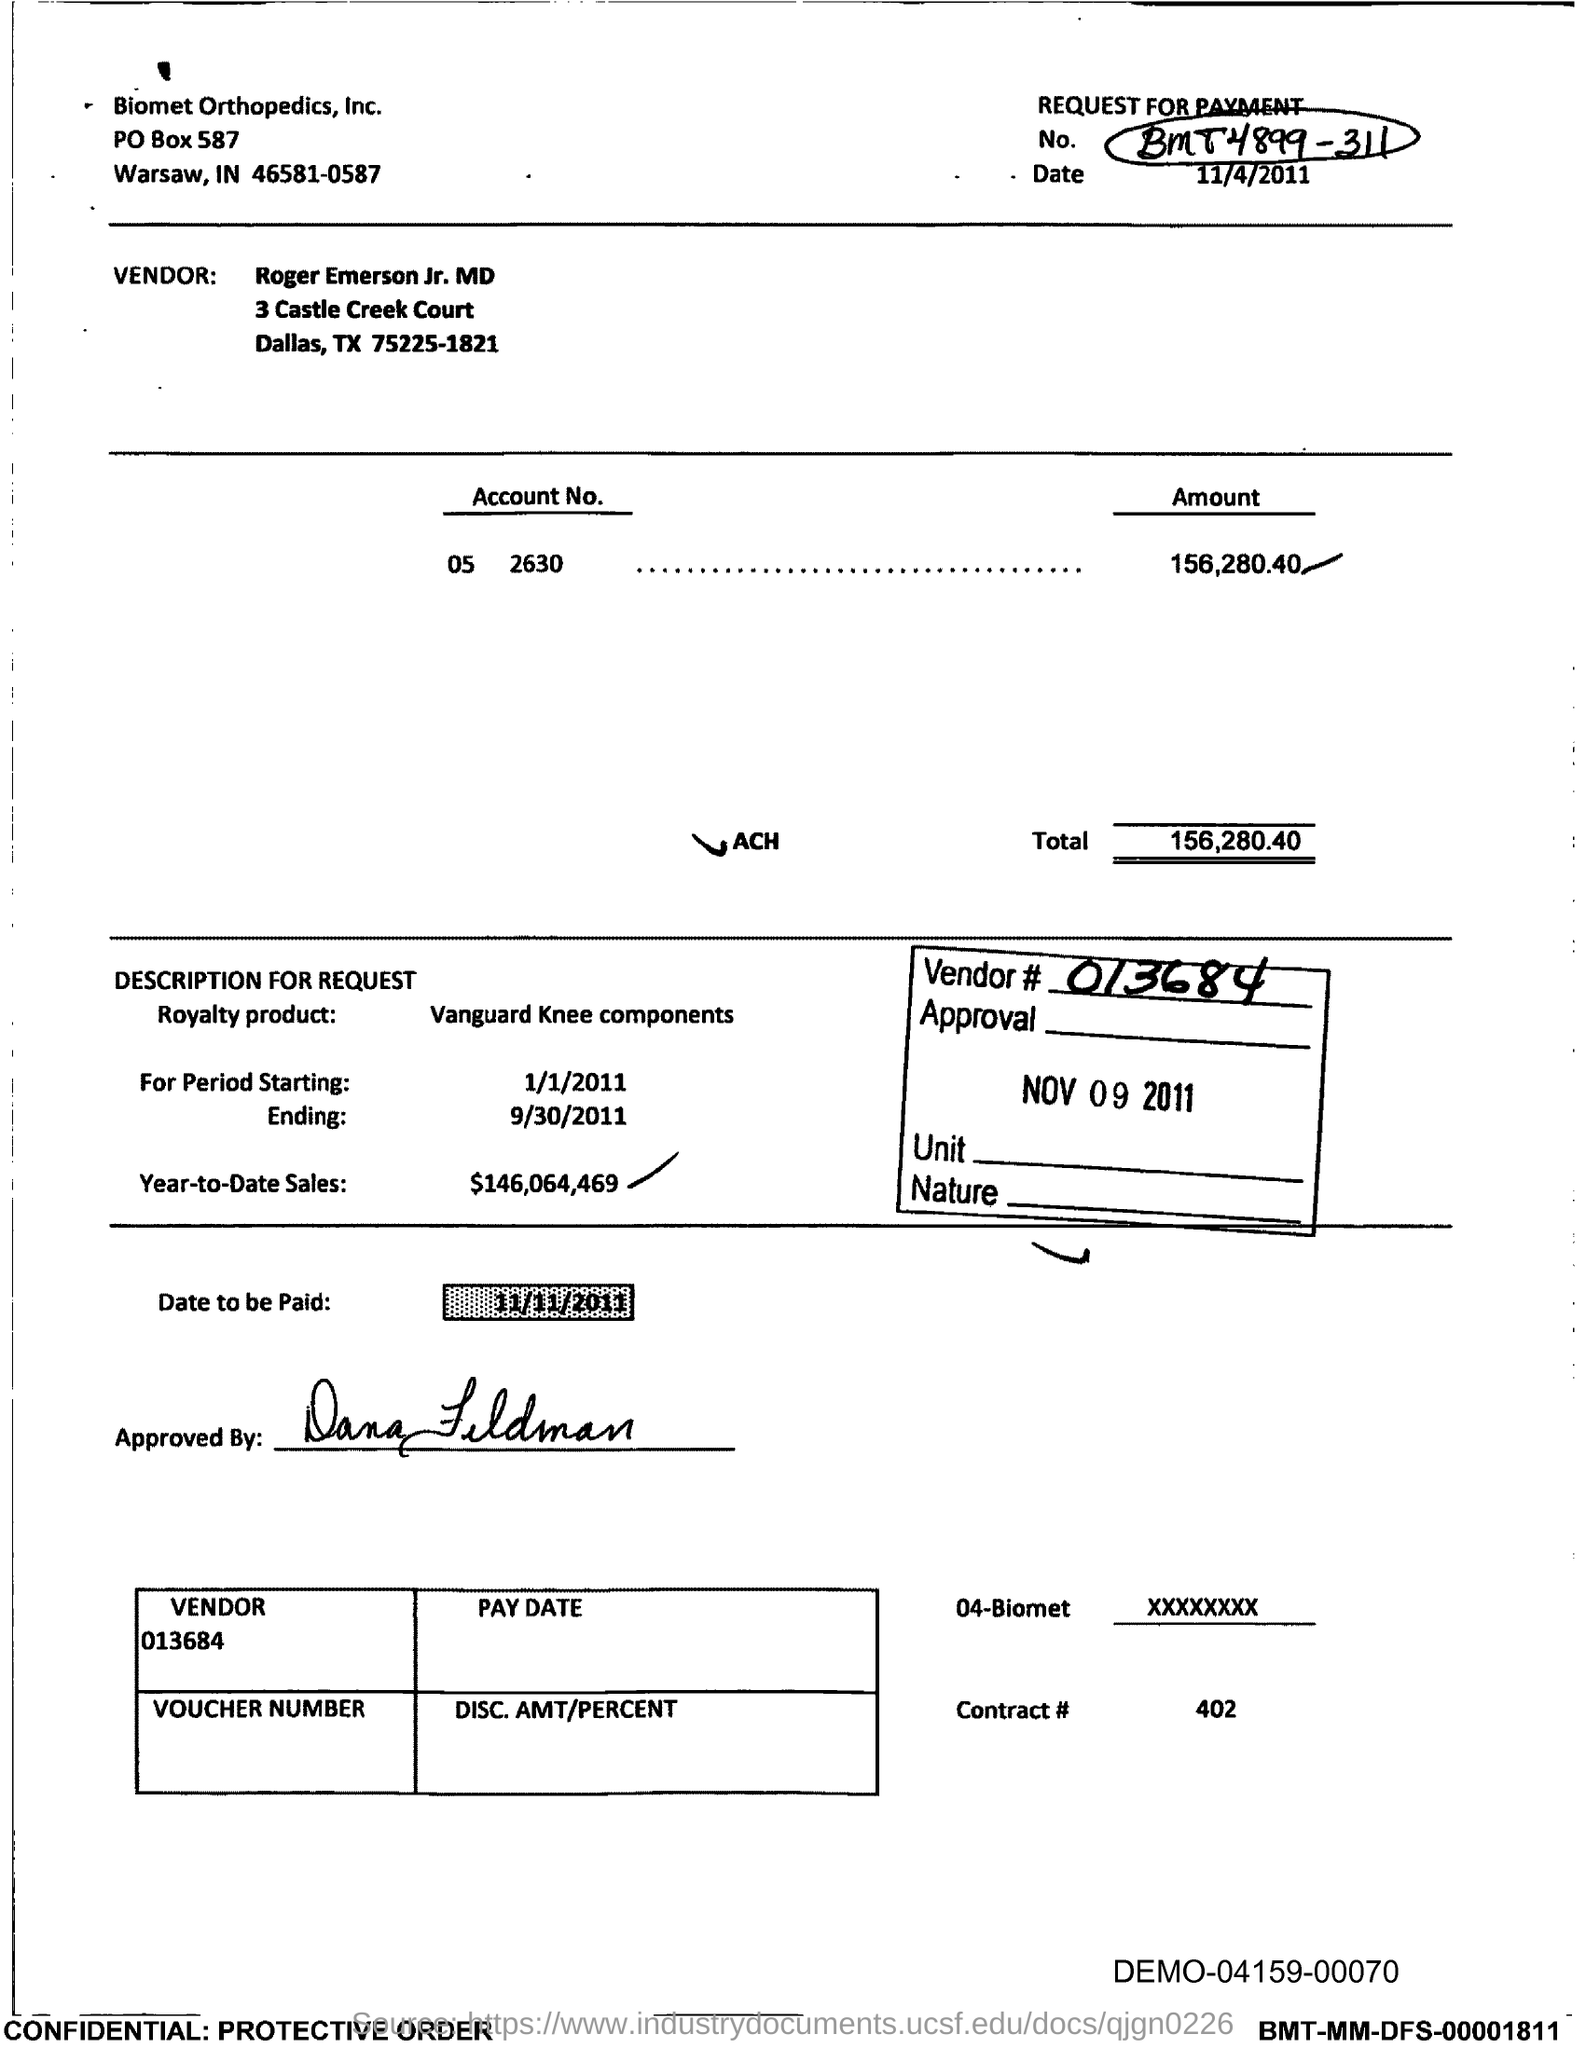List a handful of essential elements in this visual. The voucher states that the total amount mentioned is 156,280.40. The Contract # mentioned in the voucher is 402... The royalty period began on January 1, 2011. The account number provided in the voucher is 05 2630... The year-to-date sales of the royalty product are $146,064,469. 